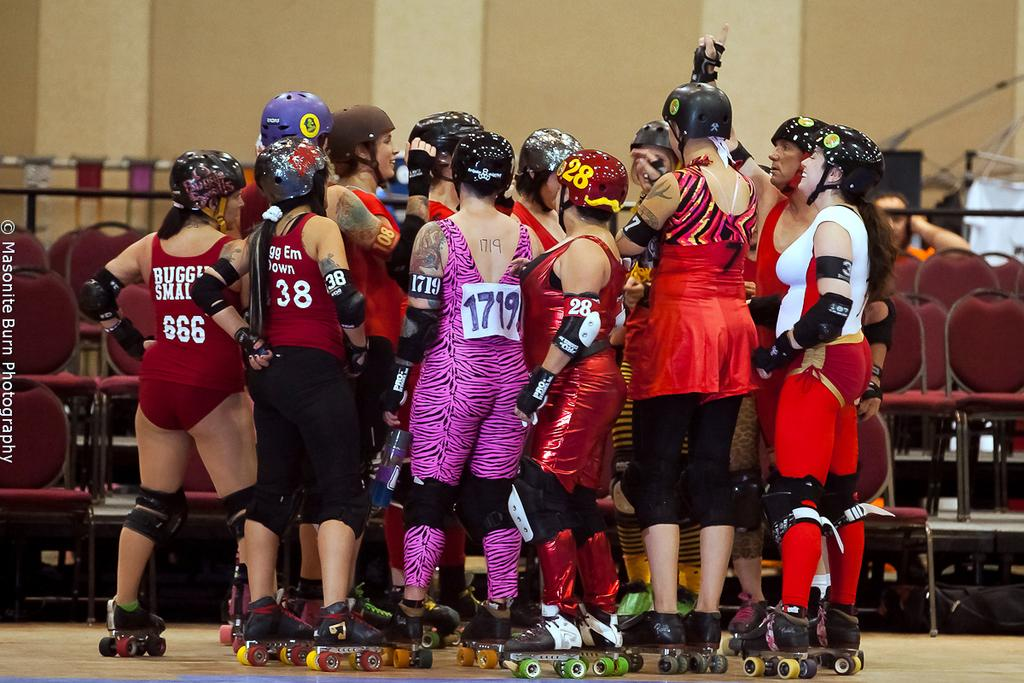<image>
Share a concise interpretation of the image provided. A person wearing a purple leotard has 1719 pinned to their back. 